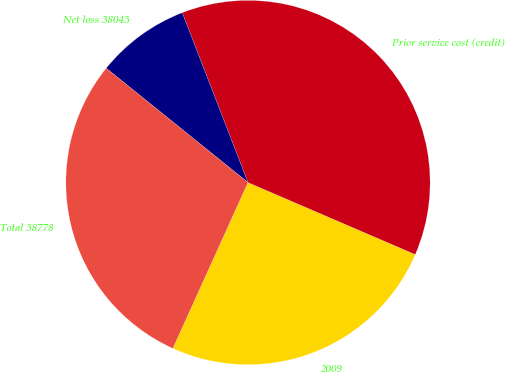Convert chart to OTSL. <chart><loc_0><loc_0><loc_500><loc_500><pie_chart><fcel>2009<fcel>Prior service cost (credit)<fcel>Net loss 38043<fcel>Total 38778<nl><fcel>25.3%<fcel>37.35%<fcel>8.32%<fcel>29.03%<nl></chart> 